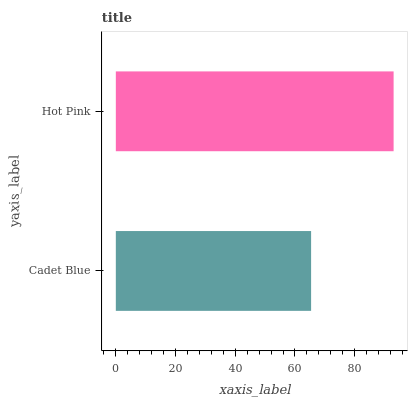Is Cadet Blue the minimum?
Answer yes or no. Yes. Is Hot Pink the maximum?
Answer yes or no. Yes. Is Hot Pink the minimum?
Answer yes or no. No. Is Hot Pink greater than Cadet Blue?
Answer yes or no. Yes. Is Cadet Blue less than Hot Pink?
Answer yes or no. Yes. Is Cadet Blue greater than Hot Pink?
Answer yes or no. No. Is Hot Pink less than Cadet Blue?
Answer yes or no. No. Is Hot Pink the high median?
Answer yes or no. Yes. Is Cadet Blue the low median?
Answer yes or no. Yes. Is Cadet Blue the high median?
Answer yes or no. No. Is Hot Pink the low median?
Answer yes or no. No. 